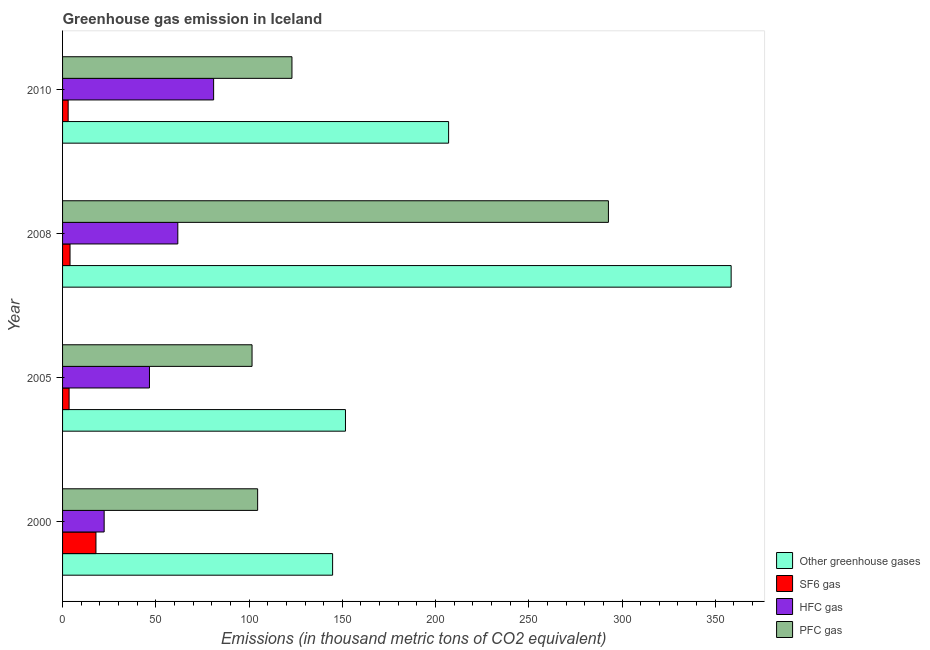How many different coloured bars are there?
Provide a succinct answer. 4. How many groups of bars are there?
Ensure brevity in your answer.  4. Are the number of bars per tick equal to the number of legend labels?
Offer a terse response. Yes. Are the number of bars on each tick of the Y-axis equal?
Offer a terse response. Yes. How many bars are there on the 4th tick from the bottom?
Offer a very short reply. 4. What is the emission of pfc gas in 2008?
Your response must be concise. 292.7. Across all years, what is the maximum emission of greenhouse gases?
Ensure brevity in your answer.  358.5. Across all years, what is the minimum emission of hfc gas?
Your response must be concise. 22.3. What is the total emission of hfc gas in the graph?
Provide a short and direct response. 211.7. What is the difference between the emission of pfc gas in 2000 and that in 2008?
Provide a short and direct response. -188.1. What is the difference between the emission of hfc gas in 2000 and the emission of pfc gas in 2008?
Provide a succinct answer. -270.4. What is the average emission of hfc gas per year?
Keep it short and to the point. 52.92. In the year 2000, what is the difference between the emission of sf6 gas and emission of hfc gas?
Offer a terse response. -4.4. In how many years, is the emission of sf6 gas greater than 160 thousand metric tons?
Your answer should be compact. 0. What is the ratio of the emission of pfc gas in 2005 to that in 2010?
Make the answer very short. 0.83. Is the difference between the emission of greenhouse gases in 2000 and 2008 greater than the difference between the emission of sf6 gas in 2000 and 2008?
Ensure brevity in your answer.  No. What is the difference between the highest and the second highest emission of sf6 gas?
Offer a very short reply. 13.9. What is the difference between the highest and the lowest emission of pfc gas?
Offer a terse response. 191.1. In how many years, is the emission of sf6 gas greater than the average emission of sf6 gas taken over all years?
Provide a short and direct response. 1. Is the sum of the emission of sf6 gas in 2005 and 2010 greater than the maximum emission of greenhouse gases across all years?
Ensure brevity in your answer.  No. What does the 3rd bar from the top in 2008 represents?
Ensure brevity in your answer.  SF6 gas. What does the 3rd bar from the bottom in 2000 represents?
Your answer should be very brief. HFC gas. Is it the case that in every year, the sum of the emission of greenhouse gases and emission of sf6 gas is greater than the emission of hfc gas?
Provide a succinct answer. Yes. How many years are there in the graph?
Ensure brevity in your answer.  4. What is the difference between two consecutive major ticks on the X-axis?
Your answer should be very brief. 50. Are the values on the major ticks of X-axis written in scientific E-notation?
Offer a terse response. No. How many legend labels are there?
Make the answer very short. 4. How are the legend labels stacked?
Give a very brief answer. Vertical. What is the title of the graph?
Provide a short and direct response. Greenhouse gas emission in Iceland. What is the label or title of the X-axis?
Your answer should be very brief. Emissions (in thousand metric tons of CO2 equivalent). What is the label or title of the Y-axis?
Your response must be concise. Year. What is the Emissions (in thousand metric tons of CO2 equivalent) of Other greenhouse gases in 2000?
Offer a very short reply. 144.8. What is the Emissions (in thousand metric tons of CO2 equivalent) of HFC gas in 2000?
Make the answer very short. 22.3. What is the Emissions (in thousand metric tons of CO2 equivalent) in PFC gas in 2000?
Your response must be concise. 104.6. What is the Emissions (in thousand metric tons of CO2 equivalent) of Other greenhouse gases in 2005?
Make the answer very short. 151.7. What is the Emissions (in thousand metric tons of CO2 equivalent) of SF6 gas in 2005?
Ensure brevity in your answer.  3.5. What is the Emissions (in thousand metric tons of CO2 equivalent) of HFC gas in 2005?
Offer a very short reply. 46.6. What is the Emissions (in thousand metric tons of CO2 equivalent) of PFC gas in 2005?
Offer a very short reply. 101.6. What is the Emissions (in thousand metric tons of CO2 equivalent) of Other greenhouse gases in 2008?
Offer a terse response. 358.5. What is the Emissions (in thousand metric tons of CO2 equivalent) in HFC gas in 2008?
Offer a terse response. 61.8. What is the Emissions (in thousand metric tons of CO2 equivalent) in PFC gas in 2008?
Your answer should be compact. 292.7. What is the Emissions (in thousand metric tons of CO2 equivalent) in Other greenhouse gases in 2010?
Ensure brevity in your answer.  207. What is the Emissions (in thousand metric tons of CO2 equivalent) of HFC gas in 2010?
Offer a very short reply. 81. What is the Emissions (in thousand metric tons of CO2 equivalent) in PFC gas in 2010?
Ensure brevity in your answer.  123. Across all years, what is the maximum Emissions (in thousand metric tons of CO2 equivalent) of Other greenhouse gases?
Ensure brevity in your answer.  358.5. Across all years, what is the maximum Emissions (in thousand metric tons of CO2 equivalent) of SF6 gas?
Your answer should be compact. 17.9. Across all years, what is the maximum Emissions (in thousand metric tons of CO2 equivalent) of HFC gas?
Ensure brevity in your answer.  81. Across all years, what is the maximum Emissions (in thousand metric tons of CO2 equivalent) of PFC gas?
Offer a terse response. 292.7. Across all years, what is the minimum Emissions (in thousand metric tons of CO2 equivalent) of Other greenhouse gases?
Your answer should be compact. 144.8. Across all years, what is the minimum Emissions (in thousand metric tons of CO2 equivalent) in HFC gas?
Provide a short and direct response. 22.3. Across all years, what is the minimum Emissions (in thousand metric tons of CO2 equivalent) in PFC gas?
Provide a short and direct response. 101.6. What is the total Emissions (in thousand metric tons of CO2 equivalent) of Other greenhouse gases in the graph?
Offer a terse response. 862. What is the total Emissions (in thousand metric tons of CO2 equivalent) of SF6 gas in the graph?
Make the answer very short. 28.4. What is the total Emissions (in thousand metric tons of CO2 equivalent) of HFC gas in the graph?
Provide a short and direct response. 211.7. What is the total Emissions (in thousand metric tons of CO2 equivalent) of PFC gas in the graph?
Offer a terse response. 621.9. What is the difference between the Emissions (in thousand metric tons of CO2 equivalent) in SF6 gas in 2000 and that in 2005?
Provide a short and direct response. 14.4. What is the difference between the Emissions (in thousand metric tons of CO2 equivalent) of HFC gas in 2000 and that in 2005?
Your answer should be compact. -24.3. What is the difference between the Emissions (in thousand metric tons of CO2 equivalent) in PFC gas in 2000 and that in 2005?
Your answer should be very brief. 3. What is the difference between the Emissions (in thousand metric tons of CO2 equivalent) of Other greenhouse gases in 2000 and that in 2008?
Give a very brief answer. -213.7. What is the difference between the Emissions (in thousand metric tons of CO2 equivalent) of SF6 gas in 2000 and that in 2008?
Offer a very short reply. 13.9. What is the difference between the Emissions (in thousand metric tons of CO2 equivalent) of HFC gas in 2000 and that in 2008?
Offer a terse response. -39.5. What is the difference between the Emissions (in thousand metric tons of CO2 equivalent) of PFC gas in 2000 and that in 2008?
Give a very brief answer. -188.1. What is the difference between the Emissions (in thousand metric tons of CO2 equivalent) in Other greenhouse gases in 2000 and that in 2010?
Keep it short and to the point. -62.2. What is the difference between the Emissions (in thousand metric tons of CO2 equivalent) in SF6 gas in 2000 and that in 2010?
Your answer should be very brief. 14.9. What is the difference between the Emissions (in thousand metric tons of CO2 equivalent) in HFC gas in 2000 and that in 2010?
Your response must be concise. -58.7. What is the difference between the Emissions (in thousand metric tons of CO2 equivalent) in PFC gas in 2000 and that in 2010?
Give a very brief answer. -18.4. What is the difference between the Emissions (in thousand metric tons of CO2 equivalent) of Other greenhouse gases in 2005 and that in 2008?
Your response must be concise. -206.8. What is the difference between the Emissions (in thousand metric tons of CO2 equivalent) in HFC gas in 2005 and that in 2008?
Your response must be concise. -15.2. What is the difference between the Emissions (in thousand metric tons of CO2 equivalent) of PFC gas in 2005 and that in 2008?
Ensure brevity in your answer.  -191.1. What is the difference between the Emissions (in thousand metric tons of CO2 equivalent) of Other greenhouse gases in 2005 and that in 2010?
Provide a short and direct response. -55.3. What is the difference between the Emissions (in thousand metric tons of CO2 equivalent) of SF6 gas in 2005 and that in 2010?
Your response must be concise. 0.5. What is the difference between the Emissions (in thousand metric tons of CO2 equivalent) in HFC gas in 2005 and that in 2010?
Your response must be concise. -34.4. What is the difference between the Emissions (in thousand metric tons of CO2 equivalent) in PFC gas in 2005 and that in 2010?
Your response must be concise. -21.4. What is the difference between the Emissions (in thousand metric tons of CO2 equivalent) of Other greenhouse gases in 2008 and that in 2010?
Give a very brief answer. 151.5. What is the difference between the Emissions (in thousand metric tons of CO2 equivalent) of SF6 gas in 2008 and that in 2010?
Offer a very short reply. 1. What is the difference between the Emissions (in thousand metric tons of CO2 equivalent) in HFC gas in 2008 and that in 2010?
Your answer should be very brief. -19.2. What is the difference between the Emissions (in thousand metric tons of CO2 equivalent) in PFC gas in 2008 and that in 2010?
Your answer should be very brief. 169.7. What is the difference between the Emissions (in thousand metric tons of CO2 equivalent) of Other greenhouse gases in 2000 and the Emissions (in thousand metric tons of CO2 equivalent) of SF6 gas in 2005?
Keep it short and to the point. 141.3. What is the difference between the Emissions (in thousand metric tons of CO2 equivalent) of Other greenhouse gases in 2000 and the Emissions (in thousand metric tons of CO2 equivalent) of HFC gas in 2005?
Your answer should be very brief. 98.2. What is the difference between the Emissions (in thousand metric tons of CO2 equivalent) in Other greenhouse gases in 2000 and the Emissions (in thousand metric tons of CO2 equivalent) in PFC gas in 2005?
Provide a succinct answer. 43.2. What is the difference between the Emissions (in thousand metric tons of CO2 equivalent) of SF6 gas in 2000 and the Emissions (in thousand metric tons of CO2 equivalent) of HFC gas in 2005?
Ensure brevity in your answer.  -28.7. What is the difference between the Emissions (in thousand metric tons of CO2 equivalent) in SF6 gas in 2000 and the Emissions (in thousand metric tons of CO2 equivalent) in PFC gas in 2005?
Offer a very short reply. -83.7. What is the difference between the Emissions (in thousand metric tons of CO2 equivalent) of HFC gas in 2000 and the Emissions (in thousand metric tons of CO2 equivalent) of PFC gas in 2005?
Make the answer very short. -79.3. What is the difference between the Emissions (in thousand metric tons of CO2 equivalent) of Other greenhouse gases in 2000 and the Emissions (in thousand metric tons of CO2 equivalent) of SF6 gas in 2008?
Offer a very short reply. 140.8. What is the difference between the Emissions (in thousand metric tons of CO2 equivalent) of Other greenhouse gases in 2000 and the Emissions (in thousand metric tons of CO2 equivalent) of HFC gas in 2008?
Offer a very short reply. 83. What is the difference between the Emissions (in thousand metric tons of CO2 equivalent) in Other greenhouse gases in 2000 and the Emissions (in thousand metric tons of CO2 equivalent) in PFC gas in 2008?
Make the answer very short. -147.9. What is the difference between the Emissions (in thousand metric tons of CO2 equivalent) in SF6 gas in 2000 and the Emissions (in thousand metric tons of CO2 equivalent) in HFC gas in 2008?
Give a very brief answer. -43.9. What is the difference between the Emissions (in thousand metric tons of CO2 equivalent) of SF6 gas in 2000 and the Emissions (in thousand metric tons of CO2 equivalent) of PFC gas in 2008?
Your response must be concise. -274.8. What is the difference between the Emissions (in thousand metric tons of CO2 equivalent) in HFC gas in 2000 and the Emissions (in thousand metric tons of CO2 equivalent) in PFC gas in 2008?
Provide a succinct answer. -270.4. What is the difference between the Emissions (in thousand metric tons of CO2 equivalent) in Other greenhouse gases in 2000 and the Emissions (in thousand metric tons of CO2 equivalent) in SF6 gas in 2010?
Keep it short and to the point. 141.8. What is the difference between the Emissions (in thousand metric tons of CO2 equivalent) in Other greenhouse gases in 2000 and the Emissions (in thousand metric tons of CO2 equivalent) in HFC gas in 2010?
Your answer should be compact. 63.8. What is the difference between the Emissions (in thousand metric tons of CO2 equivalent) of Other greenhouse gases in 2000 and the Emissions (in thousand metric tons of CO2 equivalent) of PFC gas in 2010?
Make the answer very short. 21.8. What is the difference between the Emissions (in thousand metric tons of CO2 equivalent) of SF6 gas in 2000 and the Emissions (in thousand metric tons of CO2 equivalent) of HFC gas in 2010?
Provide a succinct answer. -63.1. What is the difference between the Emissions (in thousand metric tons of CO2 equivalent) in SF6 gas in 2000 and the Emissions (in thousand metric tons of CO2 equivalent) in PFC gas in 2010?
Keep it short and to the point. -105.1. What is the difference between the Emissions (in thousand metric tons of CO2 equivalent) in HFC gas in 2000 and the Emissions (in thousand metric tons of CO2 equivalent) in PFC gas in 2010?
Your answer should be very brief. -100.7. What is the difference between the Emissions (in thousand metric tons of CO2 equivalent) of Other greenhouse gases in 2005 and the Emissions (in thousand metric tons of CO2 equivalent) of SF6 gas in 2008?
Provide a short and direct response. 147.7. What is the difference between the Emissions (in thousand metric tons of CO2 equivalent) of Other greenhouse gases in 2005 and the Emissions (in thousand metric tons of CO2 equivalent) of HFC gas in 2008?
Your response must be concise. 89.9. What is the difference between the Emissions (in thousand metric tons of CO2 equivalent) in Other greenhouse gases in 2005 and the Emissions (in thousand metric tons of CO2 equivalent) in PFC gas in 2008?
Your answer should be very brief. -141. What is the difference between the Emissions (in thousand metric tons of CO2 equivalent) in SF6 gas in 2005 and the Emissions (in thousand metric tons of CO2 equivalent) in HFC gas in 2008?
Your response must be concise. -58.3. What is the difference between the Emissions (in thousand metric tons of CO2 equivalent) in SF6 gas in 2005 and the Emissions (in thousand metric tons of CO2 equivalent) in PFC gas in 2008?
Make the answer very short. -289.2. What is the difference between the Emissions (in thousand metric tons of CO2 equivalent) of HFC gas in 2005 and the Emissions (in thousand metric tons of CO2 equivalent) of PFC gas in 2008?
Offer a very short reply. -246.1. What is the difference between the Emissions (in thousand metric tons of CO2 equivalent) of Other greenhouse gases in 2005 and the Emissions (in thousand metric tons of CO2 equivalent) of SF6 gas in 2010?
Provide a short and direct response. 148.7. What is the difference between the Emissions (in thousand metric tons of CO2 equivalent) in Other greenhouse gases in 2005 and the Emissions (in thousand metric tons of CO2 equivalent) in HFC gas in 2010?
Your response must be concise. 70.7. What is the difference between the Emissions (in thousand metric tons of CO2 equivalent) in Other greenhouse gases in 2005 and the Emissions (in thousand metric tons of CO2 equivalent) in PFC gas in 2010?
Your answer should be very brief. 28.7. What is the difference between the Emissions (in thousand metric tons of CO2 equivalent) of SF6 gas in 2005 and the Emissions (in thousand metric tons of CO2 equivalent) of HFC gas in 2010?
Offer a very short reply. -77.5. What is the difference between the Emissions (in thousand metric tons of CO2 equivalent) of SF6 gas in 2005 and the Emissions (in thousand metric tons of CO2 equivalent) of PFC gas in 2010?
Your answer should be very brief. -119.5. What is the difference between the Emissions (in thousand metric tons of CO2 equivalent) of HFC gas in 2005 and the Emissions (in thousand metric tons of CO2 equivalent) of PFC gas in 2010?
Your answer should be compact. -76.4. What is the difference between the Emissions (in thousand metric tons of CO2 equivalent) of Other greenhouse gases in 2008 and the Emissions (in thousand metric tons of CO2 equivalent) of SF6 gas in 2010?
Offer a very short reply. 355.5. What is the difference between the Emissions (in thousand metric tons of CO2 equivalent) of Other greenhouse gases in 2008 and the Emissions (in thousand metric tons of CO2 equivalent) of HFC gas in 2010?
Your answer should be compact. 277.5. What is the difference between the Emissions (in thousand metric tons of CO2 equivalent) in Other greenhouse gases in 2008 and the Emissions (in thousand metric tons of CO2 equivalent) in PFC gas in 2010?
Your response must be concise. 235.5. What is the difference between the Emissions (in thousand metric tons of CO2 equivalent) in SF6 gas in 2008 and the Emissions (in thousand metric tons of CO2 equivalent) in HFC gas in 2010?
Provide a succinct answer. -77. What is the difference between the Emissions (in thousand metric tons of CO2 equivalent) in SF6 gas in 2008 and the Emissions (in thousand metric tons of CO2 equivalent) in PFC gas in 2010?
Your answer should be compact. -119. What is the difference between the Emissions (in thousand metric tons of CO2 equivalent) in HFC gas in 2008 and the Emissions (in thousand metric tons of CO2 equivalent) in PFC gas in 2010?
Make the answer very short. -61.2. What is the average Emissions (in thousand metric tons of CO2 equivalent) in Other greenhouse gases per year?
Your response must be concise. 215.5. What is the average Emissions (in thousand metric tons of CO2 equivalent) of SF6 gas per year?
Offer a very short reply. 7.1. What is the average Emissions (in thousand metric tons of CO2 equivalent) in HFC gas per year?
Give a very brief answer. 52.92. What is the average Emissions (in thousand metric tons of CO2 equivalent) in PFC gas per year?
Provide a short and direct response. 155.47. In the year 2000, what is the difference between the Emissions (in thousand metric tons of CO2 equivalent) of Other greenhouse gases and Emissions (in thousand metric tons of CO2 equivalent) of SF6 gas?
Your answer should be compact. 126.9. In the year 2000, what is the difference between the Emissions (in thousand metric tons of CO2 equivalent) of Other greenhouse gases and Emissions (in thousand metric tons of CO2 equivalent) of HFC gas?
Offer a terse response. 122.5. In the year 2000, what is the difference between the Emissions (in thousand metric tons of CO2 equivalent) in Other greenhouse gases and Emissions (in thousand metric tons of CO2 equivalent) in PFC gas?
Offer a terse response. 40.2. In the year 2000, what is the difference between the Emissions (in thousand metric tons of CO2 equivalent) in SF6 gas and Emissions (in thousand metric tons of CO2 equivalent) in PFC gas?
Offer a terse response. -86.7. In the year 2000, what is the difference between the Emissions (in thousand metric tons of CO2 equivalent) of HFC gas and Emissions (in thousand metric tons of CO2 equivalent) of PFC gas?
Keep it short and to the point. -82.3. In the year 2005, what is the difference between the Emissions (in thousand metric tons of CO2 equivalent) of Other greenhouse gases and Emissions (in thousand metric tons of CO2 equivalent) of SF6 gas?
Your answer should be compact. 148.2. In the year 2005, what is the difference between the Emissions (in thousand metric tons of CO2 equivalent) of Other greenhouse gases and Emissions (in thousand metric tons of CO2 equivalent) of HFC gas?
Offer a terse response. 105.1. In the year 2005, what is the difference between the Emissions (in thousand metric tons of CO2 equivalent) in Other greenhouse gases and Emissions (in thousand metric tons of CO2 equivalent) in PFC gas?
Your answer should be compact. 50.1. In the year 2005, what is the difference between the Emissions (in thousand metric tons of CO2 equivalent) of SF6 gas and Emissions (in thousand metric tons of CO2 equivalent) of HFC gas?
Offer a very short reply. -43.1. In the year 2005, what is the difference between the Emissions (in thousand metric tons of CO2 equivalent) of SF6 gas and Emissions (in thousand metric tons of CO2 equivalent) of PFC gas?
Your response must be concise. -98.1. In the year 2005, what is the difference between the Emissions (in thousand metric tons of CO2 equivalent) of HFC gas and Emissions (in thousand metric tons of CO2 equivalent) of PFC gas?
Your answer should be compact. -55. In the year 2008, what is the difference between the Emissions (in thousand metric tons of CO2 equivalent) in Other greenhouse gases and Emissions (in thousand metric tons of CO2 equivalent) in SF6 gas?
Ensure brevity in your answer.  354.5. In the year 2008, what is the difference between the Emissions (in thousand metric tons of CO2 equivalent) in Other greenhouse gases and Emissions (in thousand metric tons of CO2 equivalent) in HFC gas?
Provide a short and direct response. 296.7. In the year 2008, what is the difference between the Emissions (in thousand metric tons of CO2 equivalent) of Other greenhouse gases and Emissions (in thousand metric tons of CO2 equivalent) of PFC gas?
Your answer should be very brief. 65.8. In the year 2008, what is the difference between the Emissions (in thousand metric tons of CO2 equivalent) of SF6 gas and Emissions (in thousand metric tons of CO2 equivalent) of HFC gas?
Your answer should be compact. -57.8. In the year 2008, what is the difference between the Emissions (in thousand metric tons of CO2 equivalent) in SF6 gas and Emissions (in thousand metric tons of CO2 equivalent) in PFC gas?
Ensure brevity in your answer.  -288.7. In the year 2008, what is the difference between the Emissions (in thousand metric tons of CO2 equivalent) of HFC gas and Emissions (in thousand metric tons of CO2 equivalent) of PFC gas?
Offer a terse response. -230.9. In the year 2010, what is the difference between the Emissions (in thousand metric tons of CO2 equivalent) of Other greenhouse gases and Emissions (in thousand metric tons of CO2 equivalent) of SF6 gas?
Provide a short and direct response. 204. In the year 2010, what is the difference between the Emissions (in thousand metric tons of CO2 equivalent) in Other greenhouse gases and Emissions (in thousand metric tons of CO2 equivalent) in HFC gas?
Make the answer very short. 126. In the year 2010, what is the difference between the Emissions (in thousand metric tons of CO2 equivalent) in SF6 gas and Emissions (in thousand metric tons of CO2 equivalent) in HFC gas?
Provide a succinct answer. -78. In the year 2010, what is the difference between the Emissions (in thousand metric tons of CO2 equivalent) in SF6 gas and Emissions (in thousand metric tons of CO2 equivalent) in PFC gas?
Make the answer very short. -120. In the year 2010, what is the difference between the Emissions (in thousand metric tons of CO2 equivalent) of HFC gas and Emissions (in thousand metric tons of CO2 equivalent) of PFC gas?
Offer a very short reply. -42. What is the ratio of the Emissions (in thousand metric tons of CO2 equivalent) in Other greenhouse gases in 2000 to that in 2005?
Give a very brief answer. 0.95. What is the ratio of the Emissions (in thousand metric tons of CO2 equivalent) in SF6 gas in 2000 to that in 2005?
Your answer should be compact. 5.11. What is the ratio of the Emissions (in thousand metric tons of CO2 equivalent) of HFC gas in 2000 to that in 2005?
Ensure brevity in your answer.  0.48. What is the ratio of the Emissions (in thousand metric tons of CO2 equivalent) of PFC gas in 2000 to that in 2005?
Provide a short and direct response. 1.03. What is the ratio of the Emissions (in thousand metric tons of CO2 equivalent) in Other greenhouse gases in 2000 to that in 2008?
Ensure brevity in your answer.  0.4. What is the ratio of the Emissions (in thousand metric tons of CO2 equivalent) in SF6 gas in 2000 to that in 2008?
Give a very brief answer. 4.47. What is the ratio of the Emissions (in thousand metric tons of CO2 equivalent) of HFC gas in 2000 to that in 2008?
Provide a succinct answer. 0.36. What is the ratio of the Emissions (in thousand metric tons of CO2 equivalent) of PFC gas in 2000 to that in 2008?
Your response must be concise. 0.36. What is the ratio of the Emissions (in thousand metric tons of CO2 equivalent) of Other greenhouse gases in 2000 to that in 2010?
Your answer should be very brief. 0.7. What is the ratio of the Emissions (in thousand metric tons of CO2 equivalent) in SF6 gas in 2000 to that in 2010?
Provide a short and direct response. 5.97. What is the ratio of the Emissions (in thousand metric tons of CO2 equivalent) in HFC gas in 2000 to that in 2010?
Keep it short and to the point. 0.28. What is the ratio of the Emissions (in thousand metric tons of CO2 equivalent) in PFC gas in 2000 to that in 2010?
Offer a very short reply. 0.85. What is the ratio of the Emissions (in thousand metric tons of CO2 equivalent) of Other greenhouse gases in 2005 to that in 2008?
Offer a terse response. 0.42. What is the ratio of the Emissions (in thousand metric tons of CO2 equivalent) of SF6 gas in 2005 to that in 2008?
Make the answer very short. 0.88. What is the ratio of the Emissions (in thousand metric tons of CO2 equivalent) of HFC gas in 2005 to that in 2008?
Provide a short and direct response. 0.75. What is the ratio of the Emissions (in thousand metric tons of CO2 equivalent) in PFC gas in 2005 to that in 2008?
Provide a succinct answer. 0.35. What is the ratio of the Emissions (in thousand metric tons of CO2 equivalent) of Other greenhouse gases in 2005 to that in 2010?
Your answer should be very brief. 0.73. What is the ratio of the Emissions (in thousand metric tons of CO2 equivalent) of HFC gas in 2005 to that in 2010?
Your response must be concise. 0.58. What is the ratio of the Emissions (in thousand metric tons of CO2 equivalent) of PFC gas in 2005 to that in 2010?
Provide a short and direct response. 0.83. What is the ratio of the Emissions (in thousand metric tons of CO2 equivalent) in Other greenhouse gases in 2008 to that in 2010?
Offer a very short reply. 1.73. What is the ratio of the Emissions (in thousand metric tons of CO2 equivalent) of HFC gas in 2008 to that in 2010?
Offer a terse response. 0.76. What is the ratio of the Emissions (in thousand metric tons of CO2 equivalent) of PFC gas in 2008 to that in 2010?
Your response must be concise. 2.38. What is the difference between the highest and the second highest Emissions (in thousand metric tons of CO2 equivalent) of Other greenhouse gases?
Your answer should be compact. 151.5. What is the difference between the highest and the second highest Emissions (in thousand metric tons of CO2 equivalent) of SF6 gas?
Give a very brief answer. 13.9. What is the difference between the highest and the second highest Emissions (in thousand metric tons of CO2 equivalent) of PFC gas?
Keep it short and to the point. 169.7. What is the difference between the highest and the lowest Emissions (in thousand metric tons of CO2 equivalent) of Other greenhouse gases?
Offer a terse response. 213.7. What is the difference between the highest and the lowest Emissions (in thousand metric tons of CO2 equivalent) of SF6 gas?
Keep it short and to the point. 14.9. What is the difference between the highest and the lowest Emissions (in thousand metric tons of CO2 equivalent) in HFC gas?
Your answer should be compact. 58.7. What is the difference between the highest and the lowest Emissions (in thousand metric tons of CO2 equivalent) of PFC gas?
Make the answer very short. 191.1. 